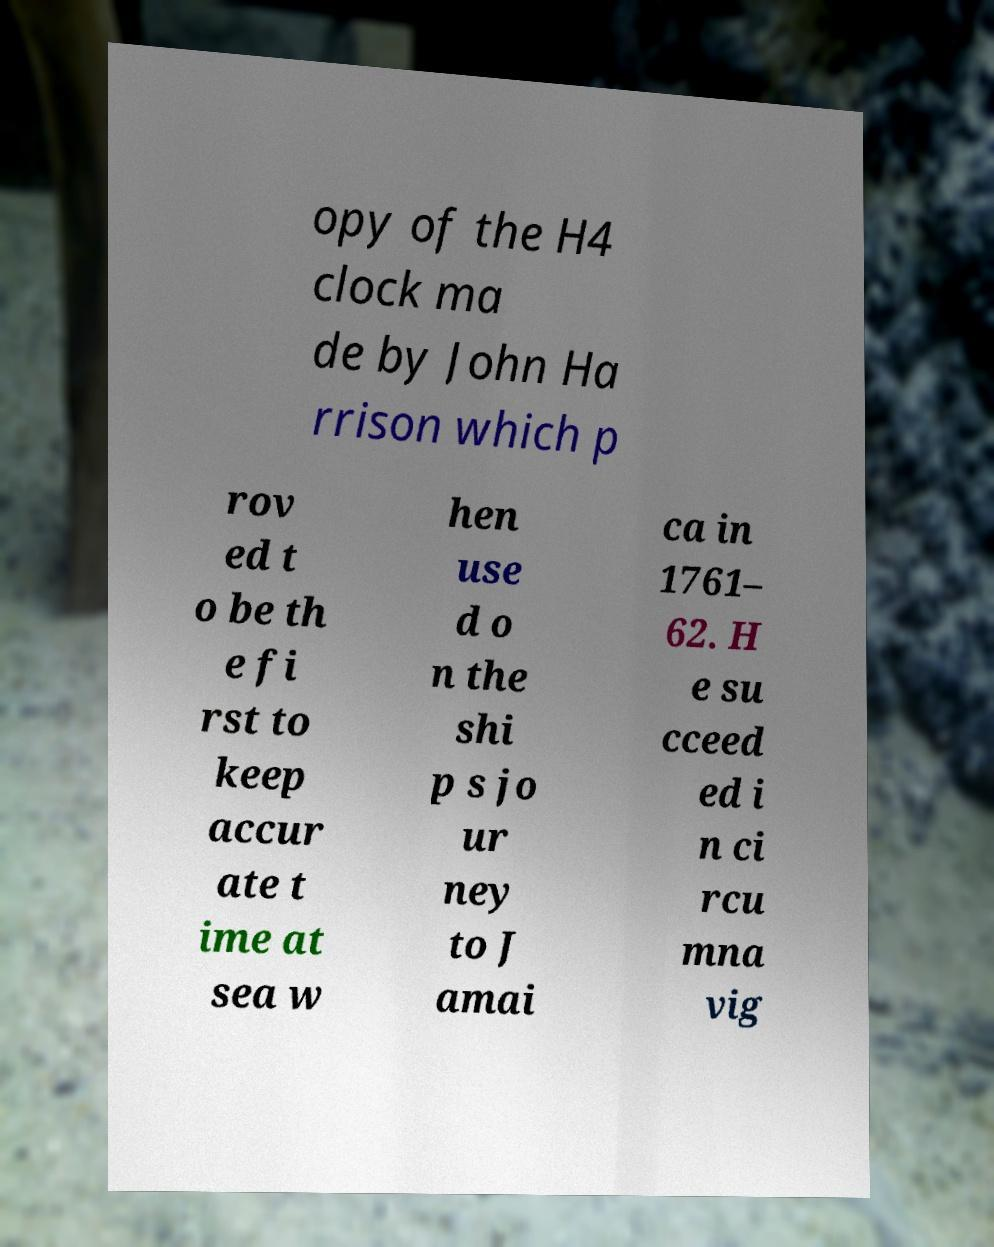Could you extract and type out the text from this image? opy of the H4 clock ma de by John Ha rrison which p rov ed t o be th e fi rst to keep accur ate t ime at sea w hen use d o n the shi p s jo ur ney to J amai ca in 1761– 62. H e su cceed ed i n ci rcu mna vig 